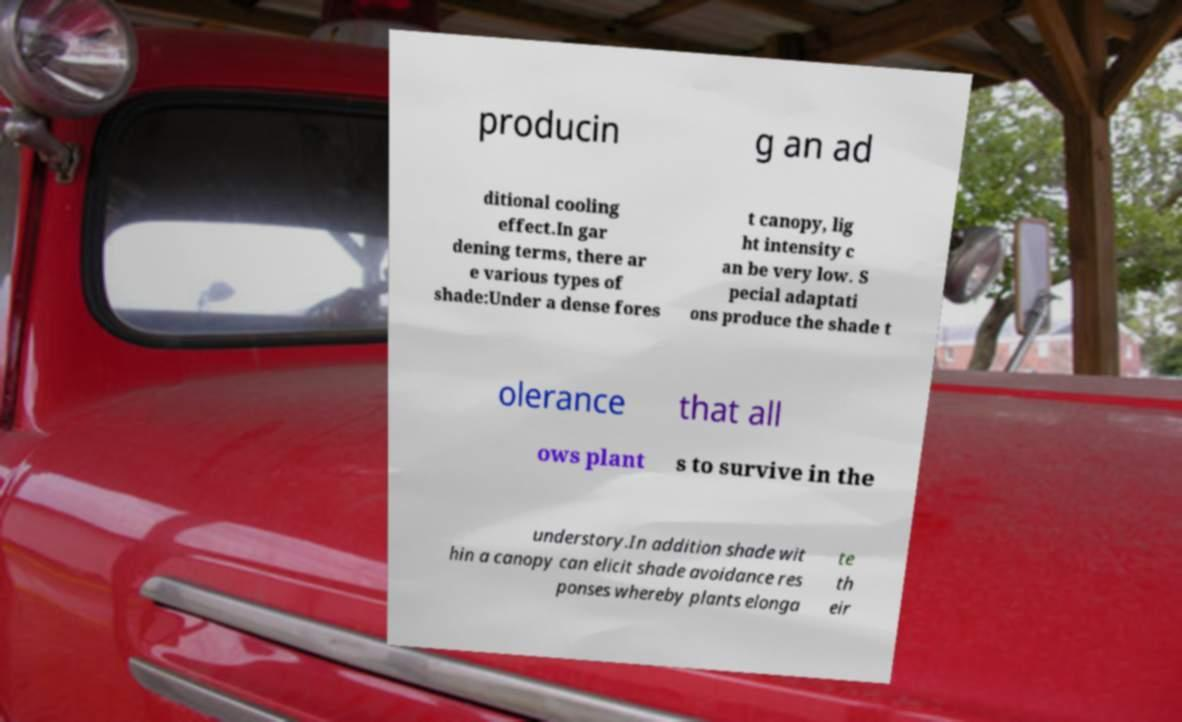Please identify and transcribe the text found in this image. producin g an ad ditional cooling effect.In gar dening terms, there ar e various types of shade:Under a dense fores t canopy, lig ht intensity c an be very low. S pecial adaptati ons produce the shade t olerance that all ows plant s to survive in the understory.In addition shade wit hin a canopy can elicit shade avoidance res ponses whereby plants elonga te th eir 